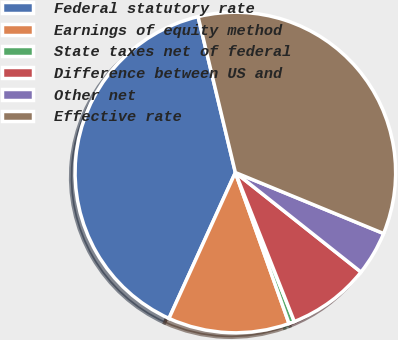<chart> <loc_0><loc_0><loc_500><loc_500><pie_chart><fcel>Federal statutory rate<fcel>Earnings of equity method<fcel>State taxes net of federal<fcel>Difference between US and<fcel>Other net<fcel>Effective rate<nl><fcel>39.46%<fcel>12.23%<fcel>0.56%<fcel>8.34%<fcel>4.45%<fcel>34.95%<nl></chart> 